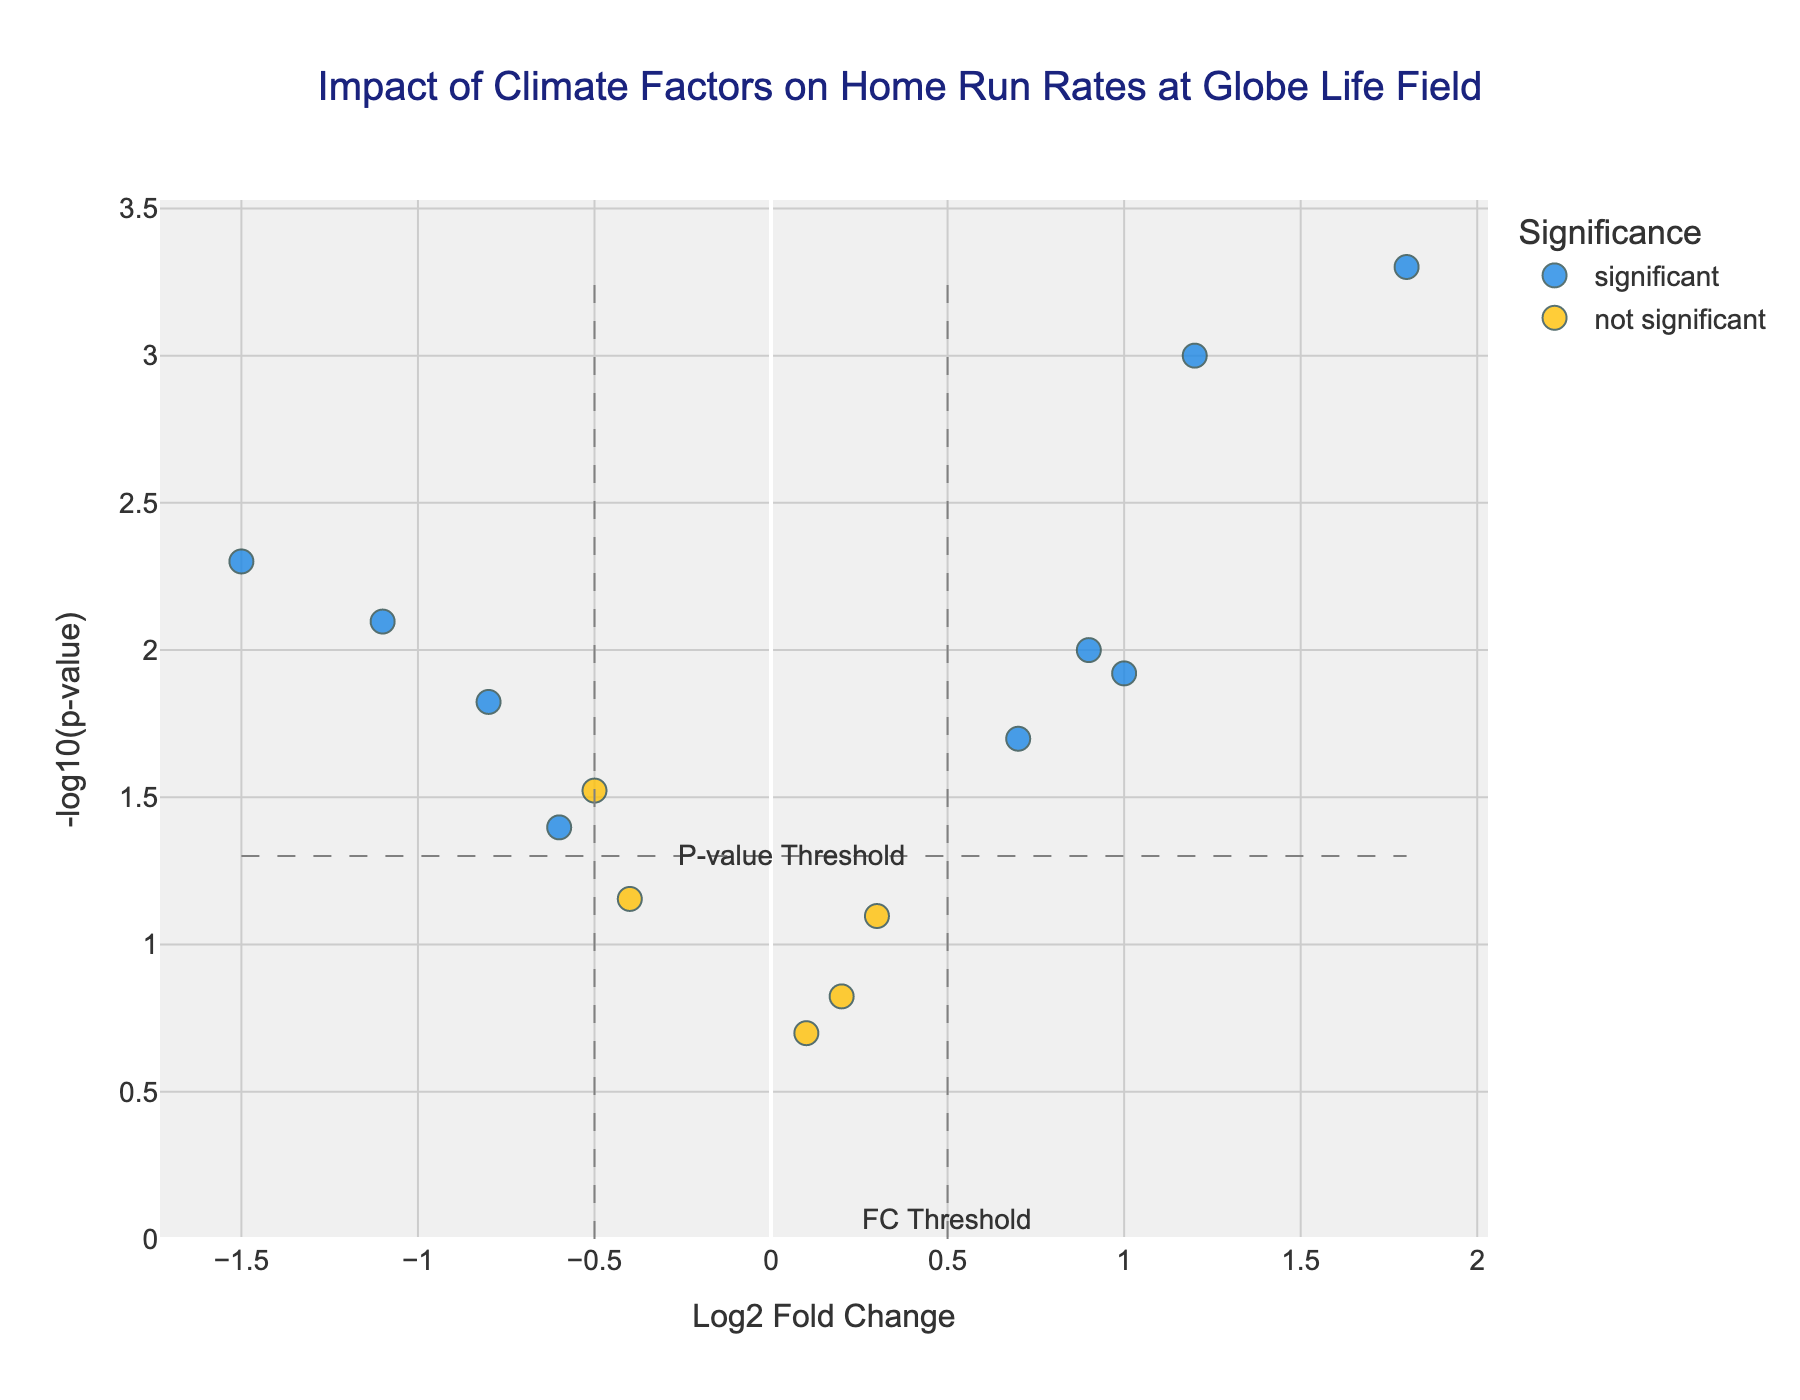What is the title of the plot? The title of the plot is typically located at the top and specifies what the plot is about. For this plot, the title is centered and reads: "Impact of Climate Factors on Home Run Rates at Globe Life Field."
Answer: Impact of Climate Factors on Home Run Rates at Globe Life Field Which factor has the highest log2 fold change? To determine the factor with the highest log2 fold change, look for the point farthest to the right on the x-axis. In this case, the highest log2 fold change is associated with the factor "Heat Index."
Answer: Heat Index Which factor has the lowest p-value? The lowest p-value corresponds to the highest y-axis value since it is -log10(p-value). The highest point on the y-axis represents the factor "Heat Index."
Answer: Heat Index How many factors are considered significant in the study? Factors are considered significant if they exceed the fold change threshold and have a p-value below the p-value threshold. These points are typically colored differently. In this case, count the number of points colored as "significant."
Answer: 8 What is the log2 fold change and p-value for precipitation? For precipitation, locate its corresponding point and then refer to its hover text. The hover text shows that for Precipitation, Log2 Fold Change is -1.5 and P-value is 0.0050.
Answer: Log2 Fold Change: -1.5, P-value: 0.0050 Which climate factor shows a significant positive influence on home run rates? A significant positive influence is indicated by positive log2 fold changes and significant coloration. "Heat Index" is the most notable factor showing a significant positive influence.
Answer: Heat Index Which climate factor shows the most significant negative influence on home run rates? Look for the point with the lowest log2 fold change and significant coloration. "Precipitation" shows the most significant negative influence on home run rates.
Answer: Precipitation Are there any factors that have a log2 fold change close to zero but are still significant? Factors with log2 fold changes near zero but still significant (colored as significant) include those that are just beyond the vertical dashed lines yet above the horizontal dashed line. This applies to "Dew Point."
Answer: Dew Point What are the fold change thresholds in this plot? The fold change thresholds are usually marked by vertical dashed lines on the x-axis. These lines are located at log2 fold changes of -0.5 and 0.5.
Answer: -0.5 and 0.5 Which factor has the second highest log2 fold change? Identify the point with the second farthest position to the right on the x-axis. This factor is "Temperature."
Answer: Temperature 